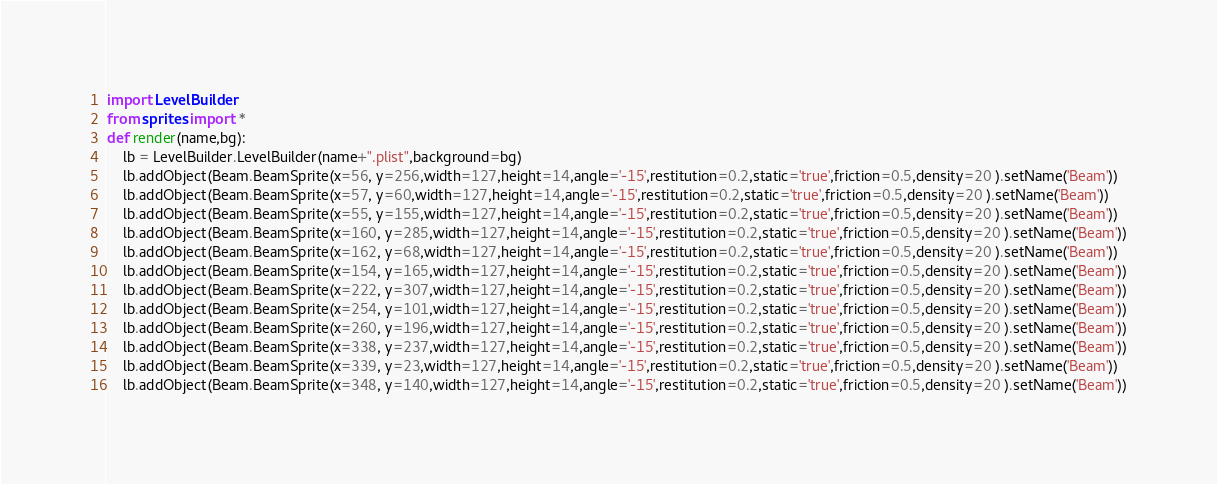Convert code to text. <code><loc_0><loc_0><loc_500><loc_500><_Python_>import LevelBuilder
from sprites import *
def render(name,bg):
    lb = LevelBuilder.LevelBuilder(name+".plist",background=bg)
    lb.addObject(Beam.BeamSprite(x=56, y=256,width=127,height=14,angle='-15',restitution=0.2,static='true',friction=0.5,density=20 ).setName('Beam'))
    lb.addObject(Beam.BeamSprite(x=57, y=60,width=127,height=14,angle='-15',restitution=0.2,static='true',friction=0.5,density=20 ).setName('Beam'))
    lb.addObject(Beam.BeamSprite(x=55, y=155,width=127,height=14,angle='-15',restitution=0.2,static='true',friction=0.5,density=20 ).setName('Beam'))
    lb.addObject(Beam.BeamSprite(x=160, y=285,width=127,height=14,angle='-15',restitution=0.2,static='true',friction=0.5,density=20 ).setName('Beam'))
    lb.addObject(Beam.BeamSprite(x=162, y=68,width=127,height=14,angle='-15',restitution=0.2,static='true',friction=0.5,density=20 ).setName('Beam'))
    lb.addObject(Beam.BeamSprite(x=154, y=165,width=127,height=14,angle='-15',restitution=0.2,static='true',friction=0.5,density=20 ).setName('Beam'))
    lb.addObject(Beam.BeamSprite(x=222, y=307,width=127,height=14,angle='-15',restitution=0.2,static='true',friction=0.5,density=20 ).setName('Beam'))
    lb.addObject(Beam.BeamSprite(x=254, y=101,width=127,height=14,angle='-15',restitution=0.2,static='true',friction=0.5,density=20 ).setName('Beam'))
    lb.addObject(Beam.BeamSprite(x=260, y=196,width=127,height=14,angle='-15',restitution=0.2,static='true',friction=0.5,density=20 ).setName('Beam'))
    lb.addObject(Beam.BeamSprite(x=338, y=237,width=127,height=14,angle='-15',restitution=0.2,static='true',friction=0.5,density=20 ).setName('Beam'))
    lb.addObject(Beam.BeamSprite(x=339, y=23,width=127,height=14,angle='-15',restitution=0.2,static='true',friction=0.5,density=20 ).setName('Beam'))
    lb.addObject(Beam.BeamSprite(x=348, y=140,width=127,height=14,angle='-15',restitution=0.2,static='true',friction=0.5,density=20 ).setName('Beam'))</code> 